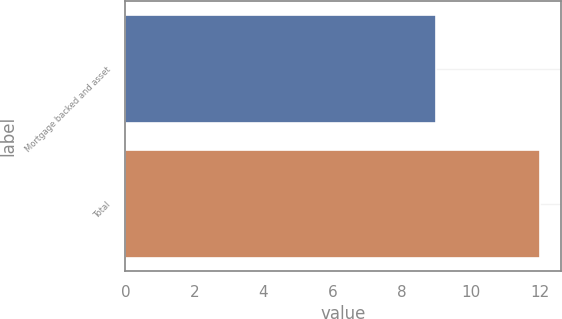Convert chart to OTSL. <chart><loc_0><loc_0><loc_500><loc_500><bar_chart><fcel>Mortgage backed and asset<fcel>Total<nl><fcel>9<fcel>12<nl></chart> 